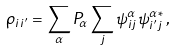Convert formula to latex. <formula><loc_0><loc_0><loc_500><loc_500>\rho _ { i i ^ { \prime } } = \sum _ { \alpha } P _ { \alpha } \sum _ { j } \psi ^ { \alpha } _ { i j } \psi ^ { \alpha \, * } _ { i ^ { \prime } j } \, ,</formula> 